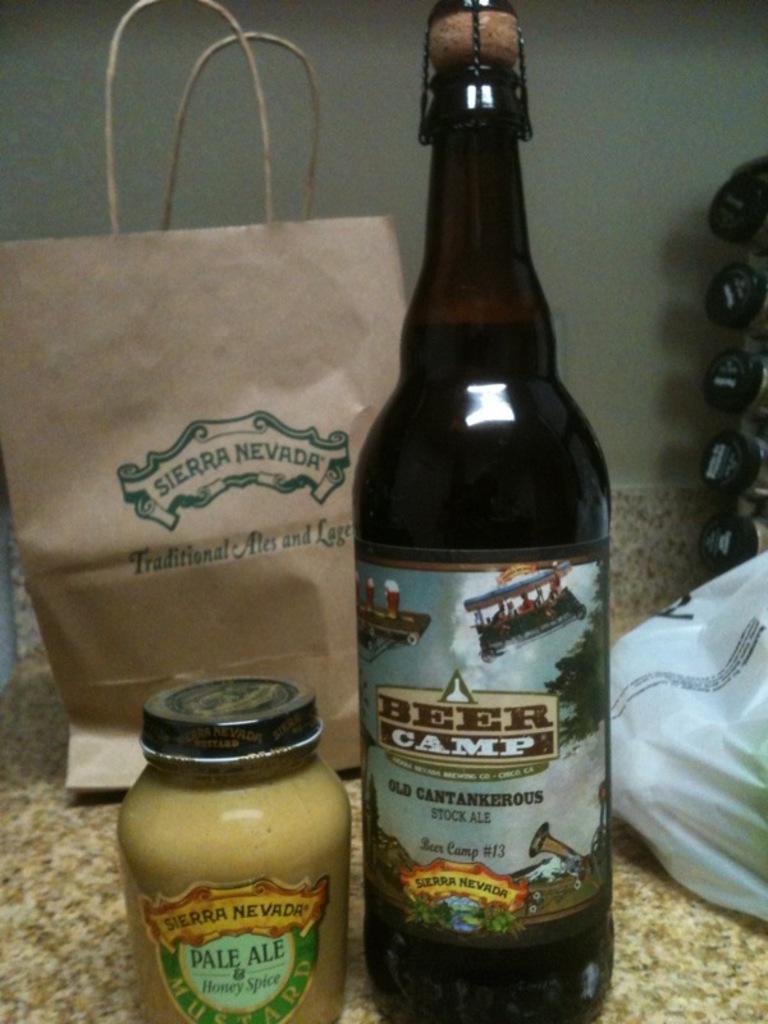Where was this purchased?
Ensure brevity in your answer.  Sierra nevada. 